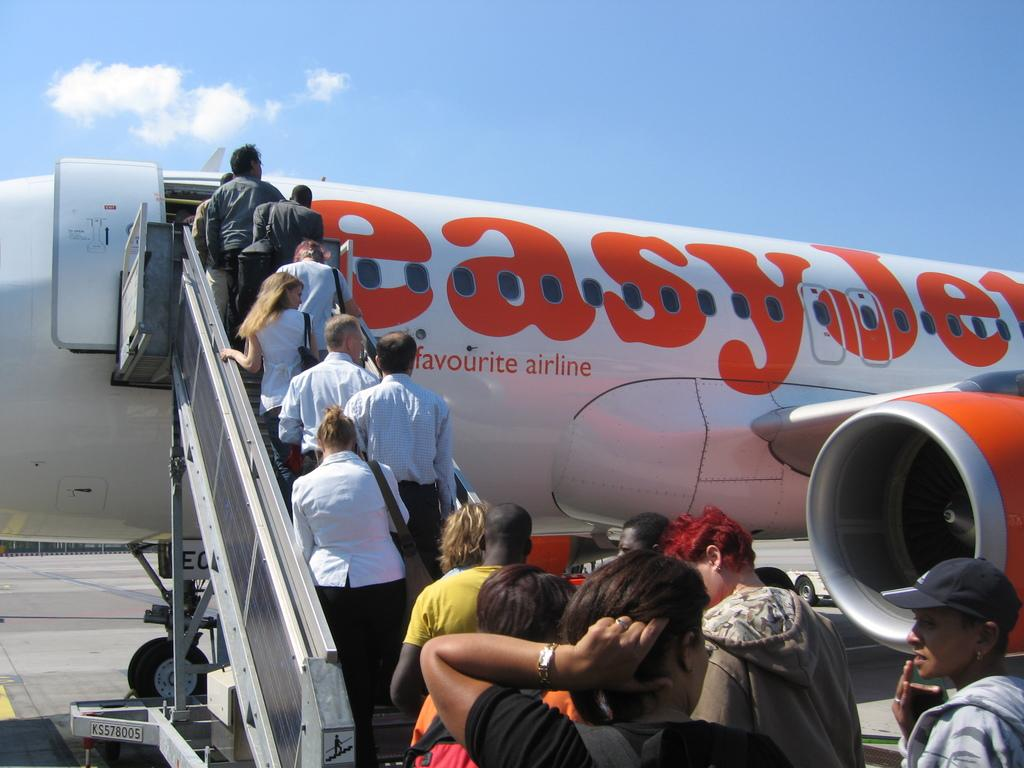<image>
Summarize the visual content of the image. The plane claims to be the favourite airline. 